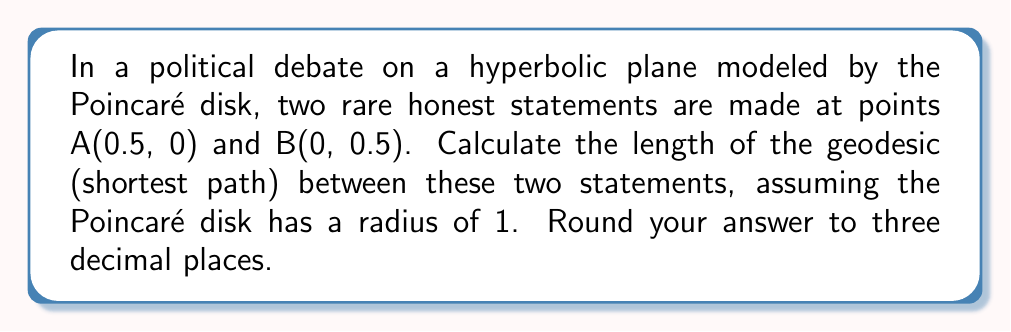Could you help me with this problem? Let's approach this step-by-step:

1) In the Poincaré disk model, geodesics are either diameters or arcs of circles that intersect the boundary of the disk orthogonally.

2) Since our points A(0.5, 0) and B(0, 0.5) are not on a diameter, the geodesic will be an arc of a circle.

3) To find this circle, we need to find its center (h, k) and radius r. The circle will pass through A and B and be perpendicular to the unit circle at these points.

4) The equations for this are:
   $$(0.5-h)^2 + k^2 = r^2$$
   $$h^2 + (0.5-k)^2 = r^2$$
   $$0.5h + 0.5k = 1$$

5) Solving this system of equations yields:
   $$h = k = \frac{1}{\sqrt{2}}, r = \frac{1}{\sqrt{2}}$$

6) The hyperbolic distance d between two points $(x_1, y_1)$ and $(x_2, y_2)$ in the Poincaré disk is given by:

   $$d = \text{acosh}\left(1 + \frac{2(x_1-x_2)^2 + 2(y_1-y_2)^2}{(1-x_1^2-y_1^2)(1-x_2^2-y_2^2)}\right)$$

7) Substituting our points:

   $$d = \text{acosh}\left(1 + \frac{2(0.5-0)^2 + 2(0-0.5)^2}{(1-0.5^2-0^2)(1-0^2-0.5^2)}\right)$$

8) Simplifying:

   $$d = \text{acosh}\left(1 + \frac{0.5}{(0.75)(0.75)}\right) = \text{acosh}\left(1 + \frac{8}{9}\right) = \text{acosh}\left(\frac{17}{9}\right)$$

9) Calculating and rounding to three decimal places:

   $$d \approx 1.144$$
Answer: 1.144 